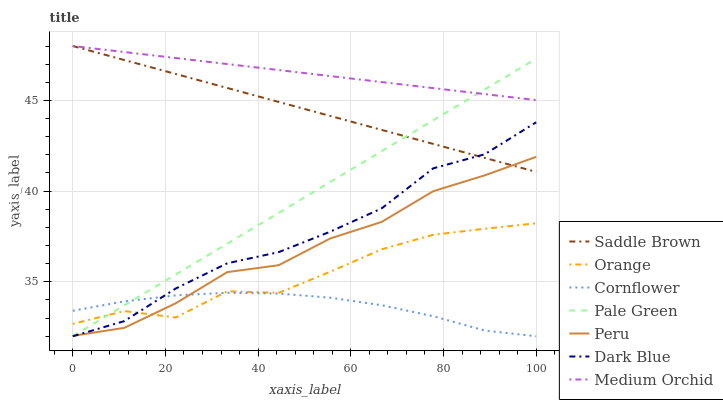Does Cornflower have the minimum area under the curve?
Answer yes or no. Yes. Does Medium Orchid have the maximum area under the curve?
Answer yes or no. Yes. Does Dark Blue have the minimum area under the curve?
Answer yes or no. No. Does Dark Blue have the maximum area under the curve?
Answer yes or no. No. Is Saddle Brown the smoothest?
Answer yes or no. Yes. Is Orange the roughest?
Answer yes or no. Yes. Is Medium Orchid the smoothest?
Answer yes or no. No. Is Medium Orchid the roughest?
Answer yes or no. No. Does Cornflower have the lowest value?
Answer yes or no. Yes. Does Medium Orchid have the lowest value?
Answer yes or no. No. Does Saddle Brown have the highest value?
Answer yes or no. Yes. Does Dark Blue have the highest value?
Answer yes or no. No. Is Cornflower less than Saddle Brown?
Answer yes or no. Yes. Is Medium Orchid greater than Peru?
Answer yes or no. Yes. Does Saddle Brown intersect Pale Green?
Answer yes or no. Yes. Is Saddle Brown less than Pale Green?
Answer yes or no. No. Is Saddle Brown greater than Pale Green?
Answer yes or no. No. Does Cornflower intersect Saddle Brown?
Answer yes or no. No. 